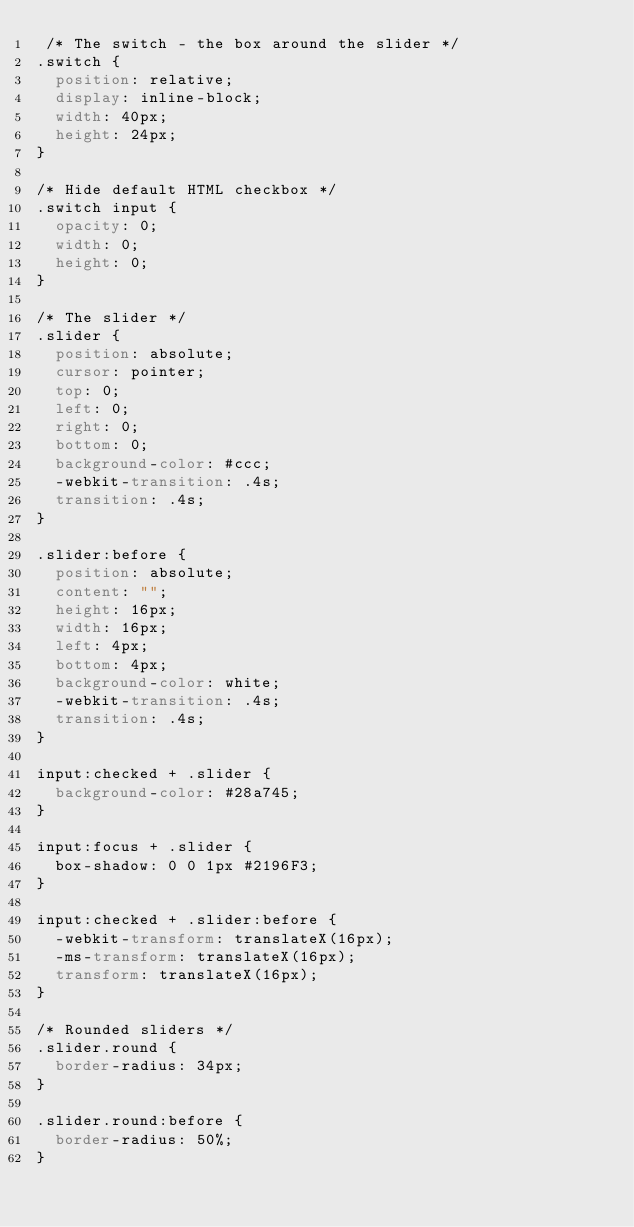<code> <loc_0><loc_0><loc_500><loc_500><_CSS_> /* The switch - the box around the slider */
.switch {
  position: relative;
  display: inline-block;
  width: 40px;
  height: 24px;
}

/* Hide default HTML checkbox */
.switch input {
  opacity: 0;
  width: 0;
  height: 0;
}

/* The slider */
.slider {
  position: absolute;
  cursor: pointer;
  top: 0;
  left: 0;
  right: 0;
  bottom: 0;
  background-color: #ccc;
  -webkit-transition: .4s;
  transition: .4s;
}

.slider:before {
  position: absolute;
  content: "";
  height: 16px;
  width: 16px;
  left: 4px;
  bottom: 4px;
  background-color: white;
  -webkit-transition: .4s;
  transition: .4s;
}

input:checked + .slider {
  background-color: #28a745;
}

input:focus + .slider {
  box-shadow: 0 0 1px #2196F3;
}

input:checked + .slider:before {
  -webkit-transform: translateX(16px);
  -ms-transform: translateX(16px);
  transform: translateX(16px);
}

/* Rounded sliders */
.slider.round {
  border-radius: 34px;
}

.slider.round:before {
  border-radius: 50%;
} </code> 